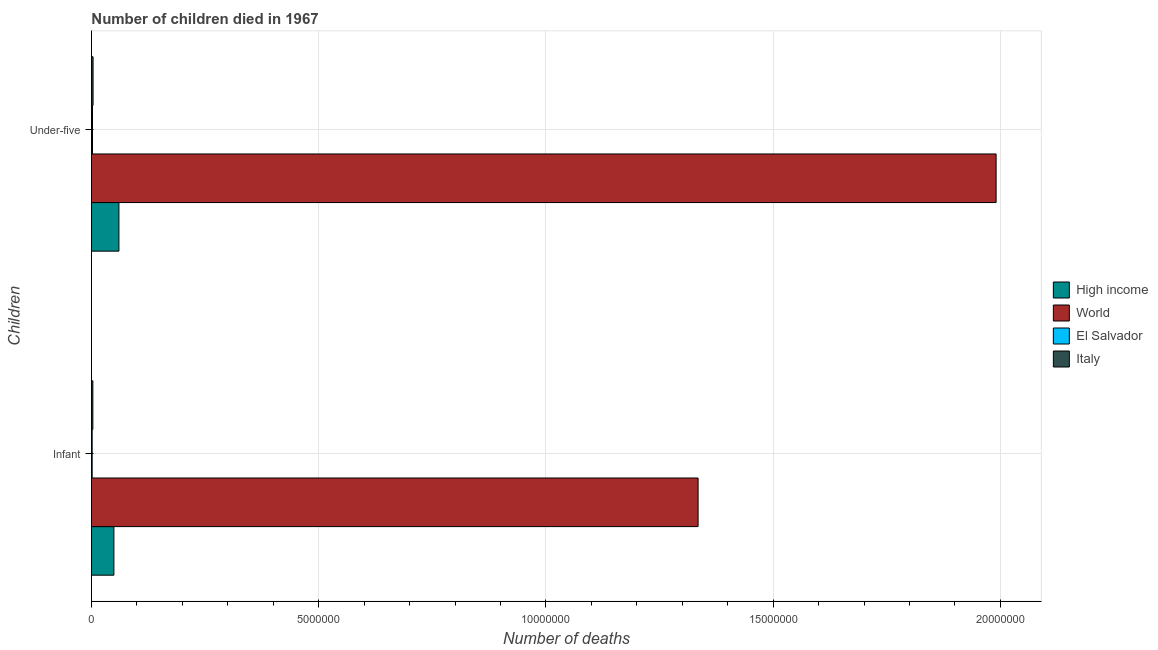How many different coloured bars are there?
Your answer should be compact. 4. Are the number of bars per tick equal to the number of legend labels?
Ensure brevity in your answer.  Yes. How many bars are there on the 1st tick from the top?
Provide a succinct answer. 4. How many bars are there on the 1st tick from the bottom?
Make the answer very short. 4. What is the label of the 2nd group of bars from the top?
Make the answer very short. Infant. What is the number of under-five deaths in High income?
Your response must be concise. 6.05e+05. Across all countries, what is the maximum number of infant deaths?
Make the answer very short. 1.33e+07. Across all countries, what is the minimum number of under-five deaths?
Your answer should be compact. 2.38e+04. In which country was the number of under-five deaths maximum?
Your answer should be compact. World. In which country was the number of infant deaths minimum?
Your answer should be compact. El Salvador. What is the total number of infant deaths in the graph?
Provide a succinct answer. 1.39e+07. What is the difference between the number of infant deaths in El Salvador and that in Italy?
Offer a terse response. -1.51e+04. What is the difference between the number of under-five deaths in High income and the number of infant deaths in El Salvador?
Ensure brevity in your answer.  5.88e+05. What is the average number of infant deaths per country?
Provide a succinct answer. 3.47e+06. What is the difference between the number of under-five deaths and number of infant deaths in High income?
Your answer should be compact. 1.10e+05. What is the ratio of the number of infant deaths in El Salvador to that in High income?
Ensure brevity in your answer.  0.03. Is the number of infant deaths in Italy less than that in High income?
Make the answer very short. Yes. Are all the bars in the graph horizontal?
Provide a succinct answer. Yes. How many countries are there in the graph?
Give a very brief answer. 4. What is the difference between two consecutive major ticks on the X-axis?
Your answer should be very brief. 5.00e+06. Are the values on the major ticks of X-axis written in scientific E-notation?
Ensure brevity in your answer.  No. Does the graph contain any zero values?
Your answer should be compact. No. How many legend labels are there?
Your answer should be very brief. 4. What is the title of the graph?
Offer a very short reply. Number of children died in 1967. What is the label or title of the X-axis?
Your answer should be very brief. Number of deaths. What is the label or title of the Y-axis?
Make the answer very short. Children. What is the Number of deaths in High income in Infant?
Give a very brief answer. 4.95e+05. What is the Number of deaths of World in Infant?
Keep it short and to the point. 1.33e+07. What is the Number of deaths of El Salvador in Infant?
Your answer should be compact. 1.65e+04. What is the Number of deaths in Italy in Infant?
Provide a succinct answer. 3.16e+04. What is the Number of deaths of High income in Under-five?
Offer a very short reply. 6.05e+05. What is the Number of deaths in World in Under-five?
Provide a short and direct response. 1.99e+07. What is the Number of deaths in El Salvador in Under-five?
Make the answer very short. 2.38e+04. What is the Number of deaths in Italy in Under-five?
Offer a very short reply. 3.61e+04. Across all Children, what is the maximum Number of deaths of High income?
Keep it short and to the point. 6.05e+05. Across all Children, what is the maximum Number of deaths in World?
Ensure brevity in your answer.  1.99e+07. Across all Children, what is the maximum Number of deaths of El Salvador?
Make the answer very short. 2.38e+04. Across all Children, what is the maximum Number of deaths of Italy?
Ensure brevity in your answer.  3.61e+04. Across all Children, what is the minimum Number of deaths of High income?
Your response must be concise. 4.95e+05. Across all Children, what is the minimum Number of deaths of World?
Keep it short and to the point. 1.33e+07. Across all Children, what is the minimum Number of deaths of El Salvador?
Give a very brief answer. 1.65e+04. Across all Children, what is the minimum Number of deaths in Italy?
Make the answer very short. 3.16e+04. What is the total Number of deaths of High income in the graph?
Offer a very short reply. 1.10e+06. What is the total Number of deaths in World in the graph?
Keep it short and to the point. 3.33e+07. What is the total Number of deaths of El Salvador in the graph?
Offer a very short reply. 4.04e+04. What is the total Number of deaths in Italy in the graph?
Give a very brief answer. 6.77e+04. What is the difference between the Number of deaths in High income in Infant and that in Under-five?
Provide a succinct answer. -1.10e+05. What is the difference between the Number of deaths in World in Infant and that in Under-five?
Ensure brevity in your answer.  -6.56e+06. What is the difference between the Number of deaths of El Salvador in Infant and that in Under-five?
Make the answer very short. -7319. What is the difference between the Number of deaths of Italy in Infant and that in Under-five?
Keep it short and to the point. -4532. What is the difference between the Number of deaths in High income in Infant and the Number of deaths in World in Under-five?
Keep it short and to the point. -1.94e+07. What is the difference between the Number of deaths in High income in Infant and the Number of deaths in El Salvador in Under-five?
Your answer should be compact. 4.71e+05. What is the difference between the Number of deaths of High income in Infant and the Number of deaths of Italy in Under-five?
Offer a very short reply. 4.59e+05. What is the difference between the Number of deaths in World in Infant and the Number of deaths in El Salvador in Under-five?
Offer a terse response. 1.33e+07. What is the difference between the Number of deaths of World in Infant and the Number of deaths of Italy in Under-five?
Ensure brevity in your answer.  1.33e+07. What is the difference between the Number of deaths of El Salvador in Infant and the Number of deaths of Italy in Under-five?
Keep it short and to the point. -1.96e+04. What is the average Number of deaths in High income per Children?
Keep it short and to the point. 5.50e+05. What is the average Number of deaths in World per Children?
Your response must be concise. 1.66e+07. What is the average Number of deaths in El Salvador per Children?
Your answer should be compact. 2.02e+04. What is the average Number of deaths of Italy per Children?
Provide a short and direct response. 3.38e+04. What is the difference between the Number of deaths of High income and Number of deaths of World in Infant?
Offer a terse response. -1.29e+07. What is the difference between the Number of deaths in High income and Number of deaths in El Salvador in Infant?
Your answer should be compact. 4.78e+05. What is the difference between the Number of deaths of High income and Number of deaths of Italy in Infant?
Your answer should be very brief. 4.63e+05. What is the difference between the Number of deaths in World and Number of deaths in El Salvador in Infant?
Make the answer very short. 1.33e+07. What is the difference between the Number of deaths in World and Number of deaths in Italy in Infant?
Ensure brevity in your answer.  1.33e+07. What is the difference between the Number of deaths in El Salvador and Number of deaths in Italy in Infant?
Give a very brief answer. -1.51e+04. What is the difference between the Number of deaths in High income and Number of deaths in World in Under-five?
Provide a succinct answer. -1.93e+07. What is the difference between the Number of deaths of High income and Number of deaths of El Salvador in Under-five?
Make the answer very short. 5.81e+05. What is the difference between the Number of deaths of High income and Number of deaths of Italy in Under-five?
Your answer should be compact. 5.69e+05. What is the difference between the Number of deaths in World and Number of deaths in El Salvador in Under-five?
Offer a terse response. 1.99e+07. What is the difference between the Number of deaths of World and Number of deaths of Italy in Under-five?
Offer a terse response. 1.99e+07. What is the difference between the Number of deaths in El Salvador and Number of deaths in Italy in Under-five?
Keep it short and to the point. -1.23e+04. What is the ratio of the Number of deaths of High income in Infant to that in Under-five?
Your answer should be very brief. 0.82. What is the ratio of the Number of deaths in World in Infant to that in Under-five?
Your answer should be very brief. 0.67. What is the ratio of the Number of deaths of El Salvador in Infant to that in Under-five?
Your response must be concise. 0.69. What is the ratio of the Number of deaths of Italy in Infant to that in Under-five?
Provide a succinct answer. 0.87. What is the difference between the highest and the second highest Number of deaths of High income?
Your answer should be compact. 1.10e+05. What is the difference between the highest and the second highest Number of deaths of World?
Provide a short and direct response. 6.56e+06. What is the difference between the highest and the second highest Number of deaths of El Salvador?
Make the answer very short. 7319. What is the difference between the highest and the second highest Number of deaths in Italy?
Your answer should be compact. 4532. What is the difference between the highest and the lowest Number of deaths of High income?
Your answer should be very brief. 1.10e+05. What is the difference between the highest and the lowest Number of deaths of World?
Give a very brief answer. 6.56e+06. What is the difference between the highest and the lowest Number of deaths of El Salvador?
Make the answer very short. 7319. What is the difference between the highest and the lowest Number of deaths of Italy?
Ensure brevity in your answer.  4532. 